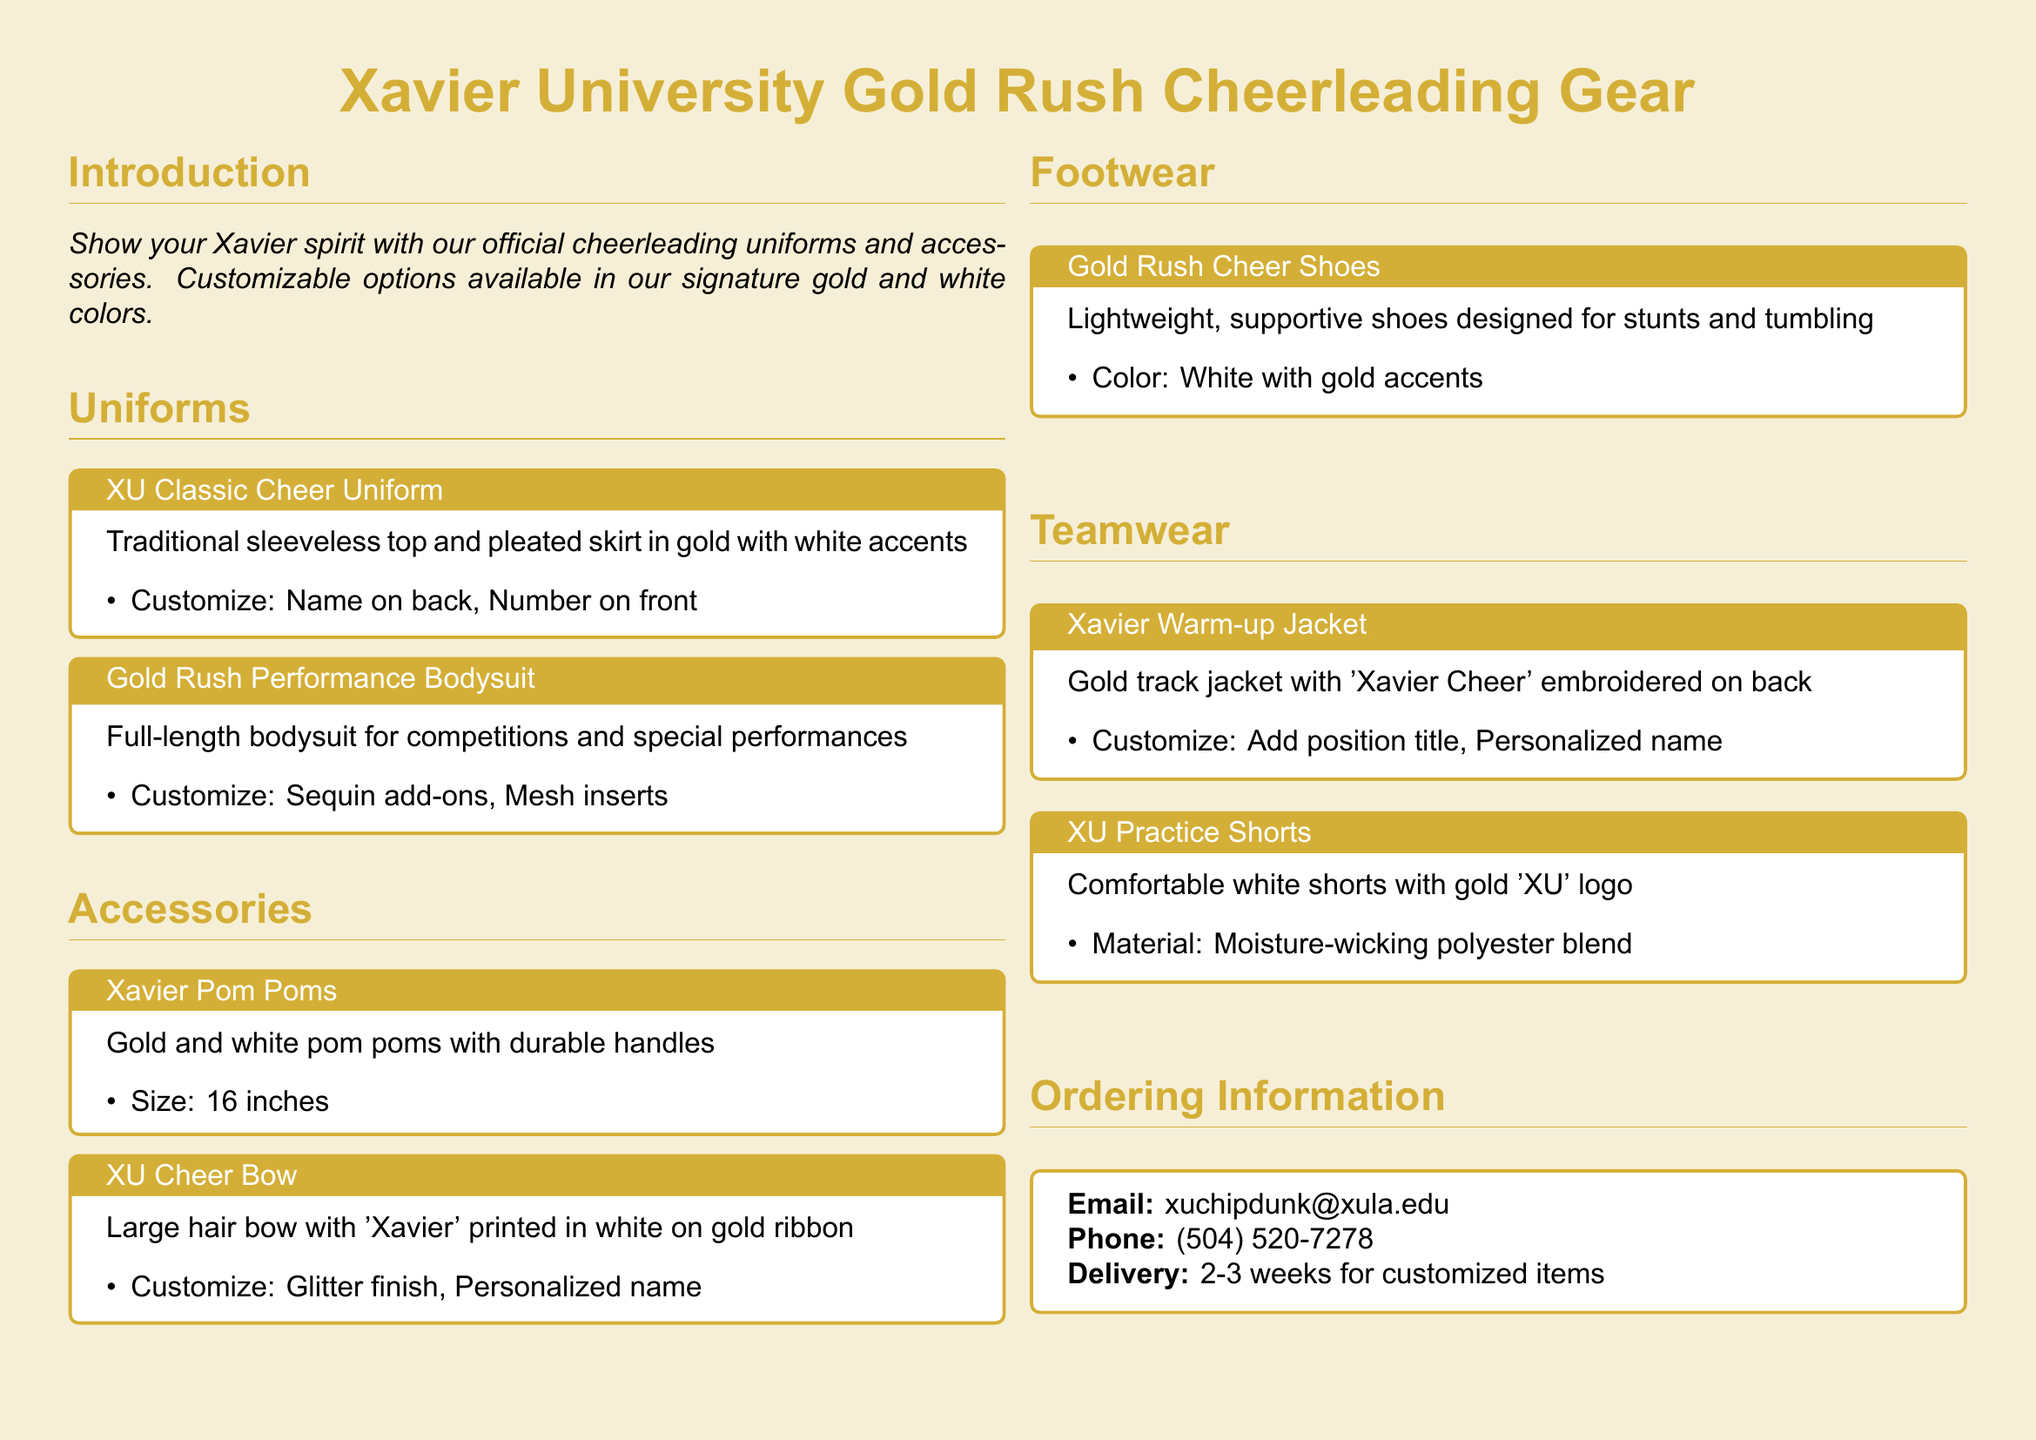What colors are used in the Xavier cheerleading gear? The cheerleading gear features the signature gold and white colors.
Answer: gold and white What is the size of the Xavier pom poms? The document states that the size of the pom poms is 16 inches.
Answer: 16 inches What is one customization option for the Gold Rush Performance Bodysuit? The bodysuit offers customization options like sequin add-ons.
Answer: Sequin add-ons How long does delivery take for customized items? The document mentions that delivery takes 2-3 weeks for customized items.
Answer: 2-3 weeks What material are the XU Practice Shorts made of? The shorts are made from a moisture-wicking polyester blend.
Answer: Moisture-wicking polyester blend What is the title on the Xavier Warm-up Jacket? The title embroidered on the jacket is 'Xavier Cheer'.
Answer: Xavier Cheer Can the XU Cheer Bow be personalized? Yes, the bow can be personalized with a name.
Answer: Personalized name What type of shoes are the Gold Rush Cheer Shoes designed for? The shoes are designed for stunts and tumbling.
Answer: Stunts and tumbling 